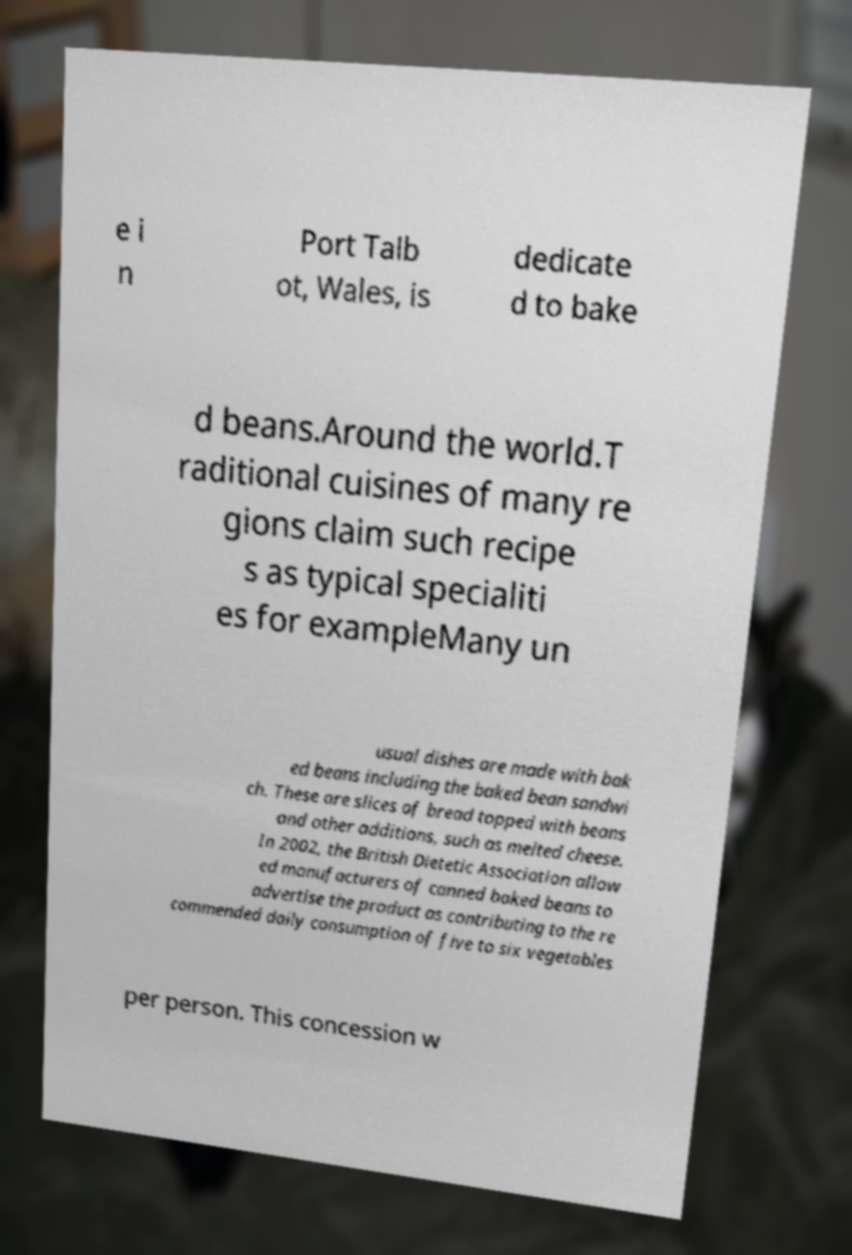Could you extract and type out the text from this image? e i n Port Talb ot, Wales, is dedicate d to bake d beans.Around the world.T raditional cuisines of many re gions claim such recipe s as typical specialiti es for exampleMany un usual dishes are made with bak ed beans including the baked bean sandwi ch. These are slices of bread topped with beans and other additions, such as melted cheese. In 2002, the British Dietetic Association allow ed manufacturers of canned baked beans to advertise the product as contributing to the re commended daily consumption of five to six vegetables per person. This concession w 